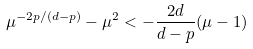<formula> <loc_0><loc_0><loc_500><loc_500>\mu ^ { - 2 p / ( d - p ) } - \mu ^ { 2 } < - \frac { 2 d } { d - p } ( \mu - 1 )</formula> 